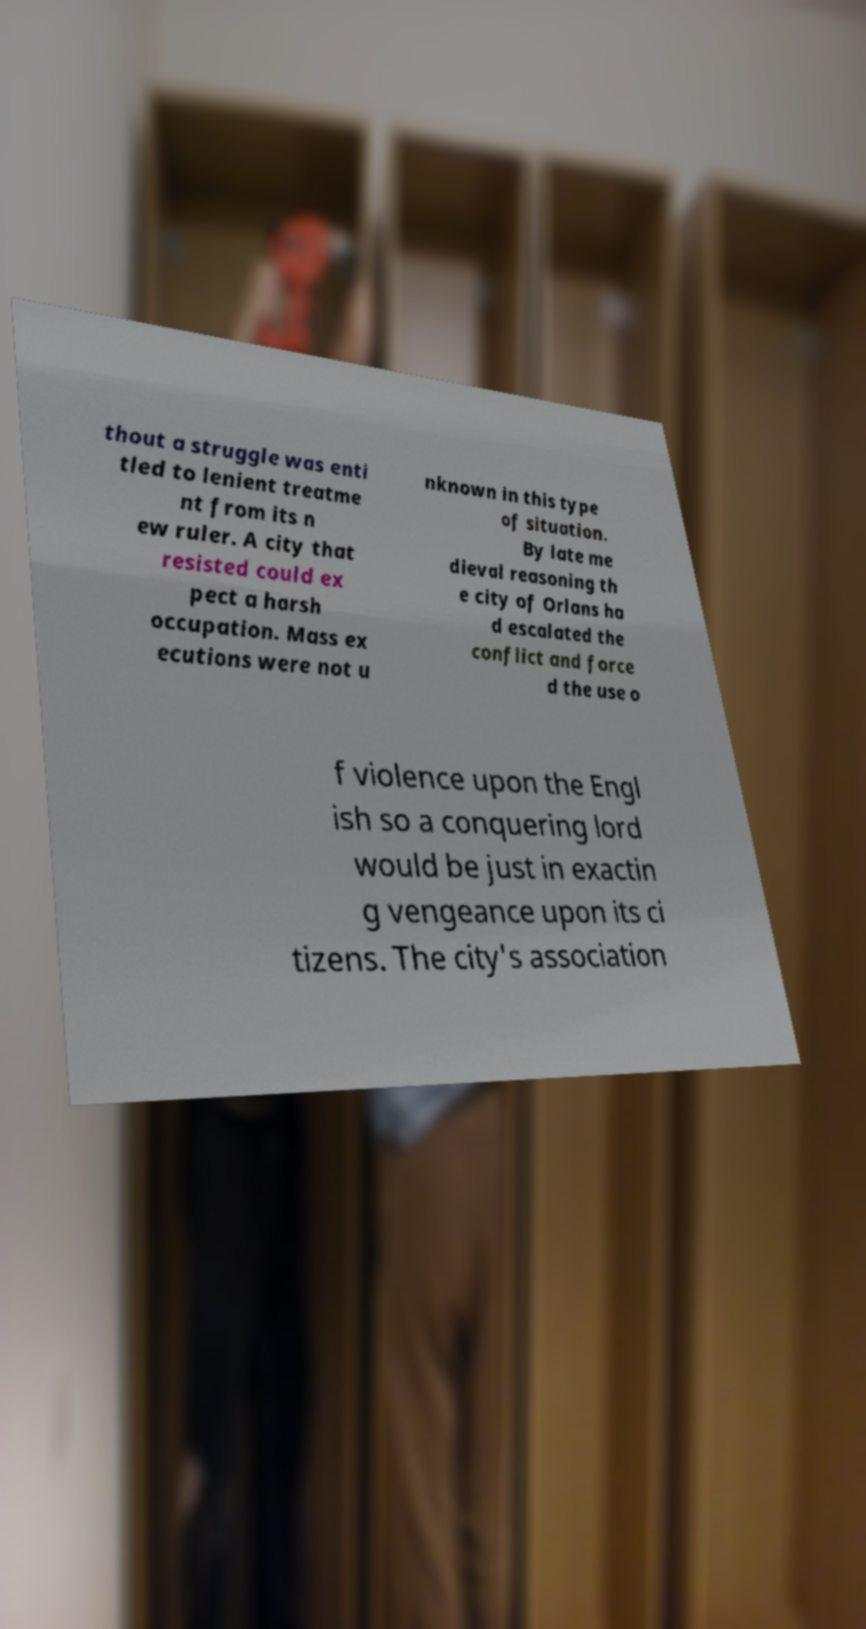I need the written content from this picture converted into text. Can you do that? thout a struggle was enti tled to lenient treatme nt from its n ew ruler. A city that resisted could ex pect a harsh occupation. Mass ex ecutions were not u nknown in this type of situation. By late me dieval reasoning th e city of Orlans ha d escalated the conflict and force d the use o f violence upon the Engl ish so a conquering lord would be just in exactin g vengeance upon its ci tizens. The city's association 